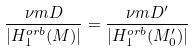<formula> <loc_0><loc_0><loc_500><loc_500>\frac { \nu m { D } } { | H _ { 1 } ^ { o r b } ( M ) | } = \frac { \nu m { D ^ { \prime } } } { | H _ { 1 } ^ { o r b } ( M ^ { \prime } _ { 0 } ) | }</formula> 